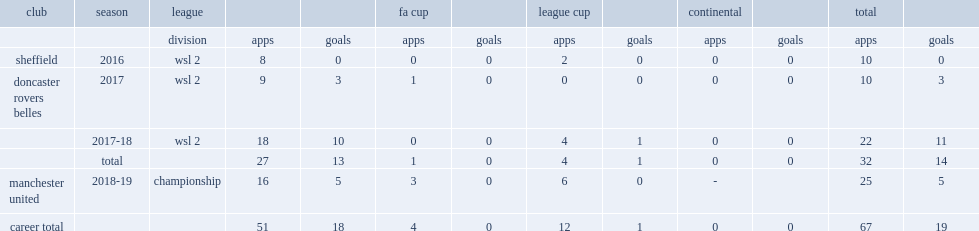Which club did hanson play for in 2016? Sheffield. 